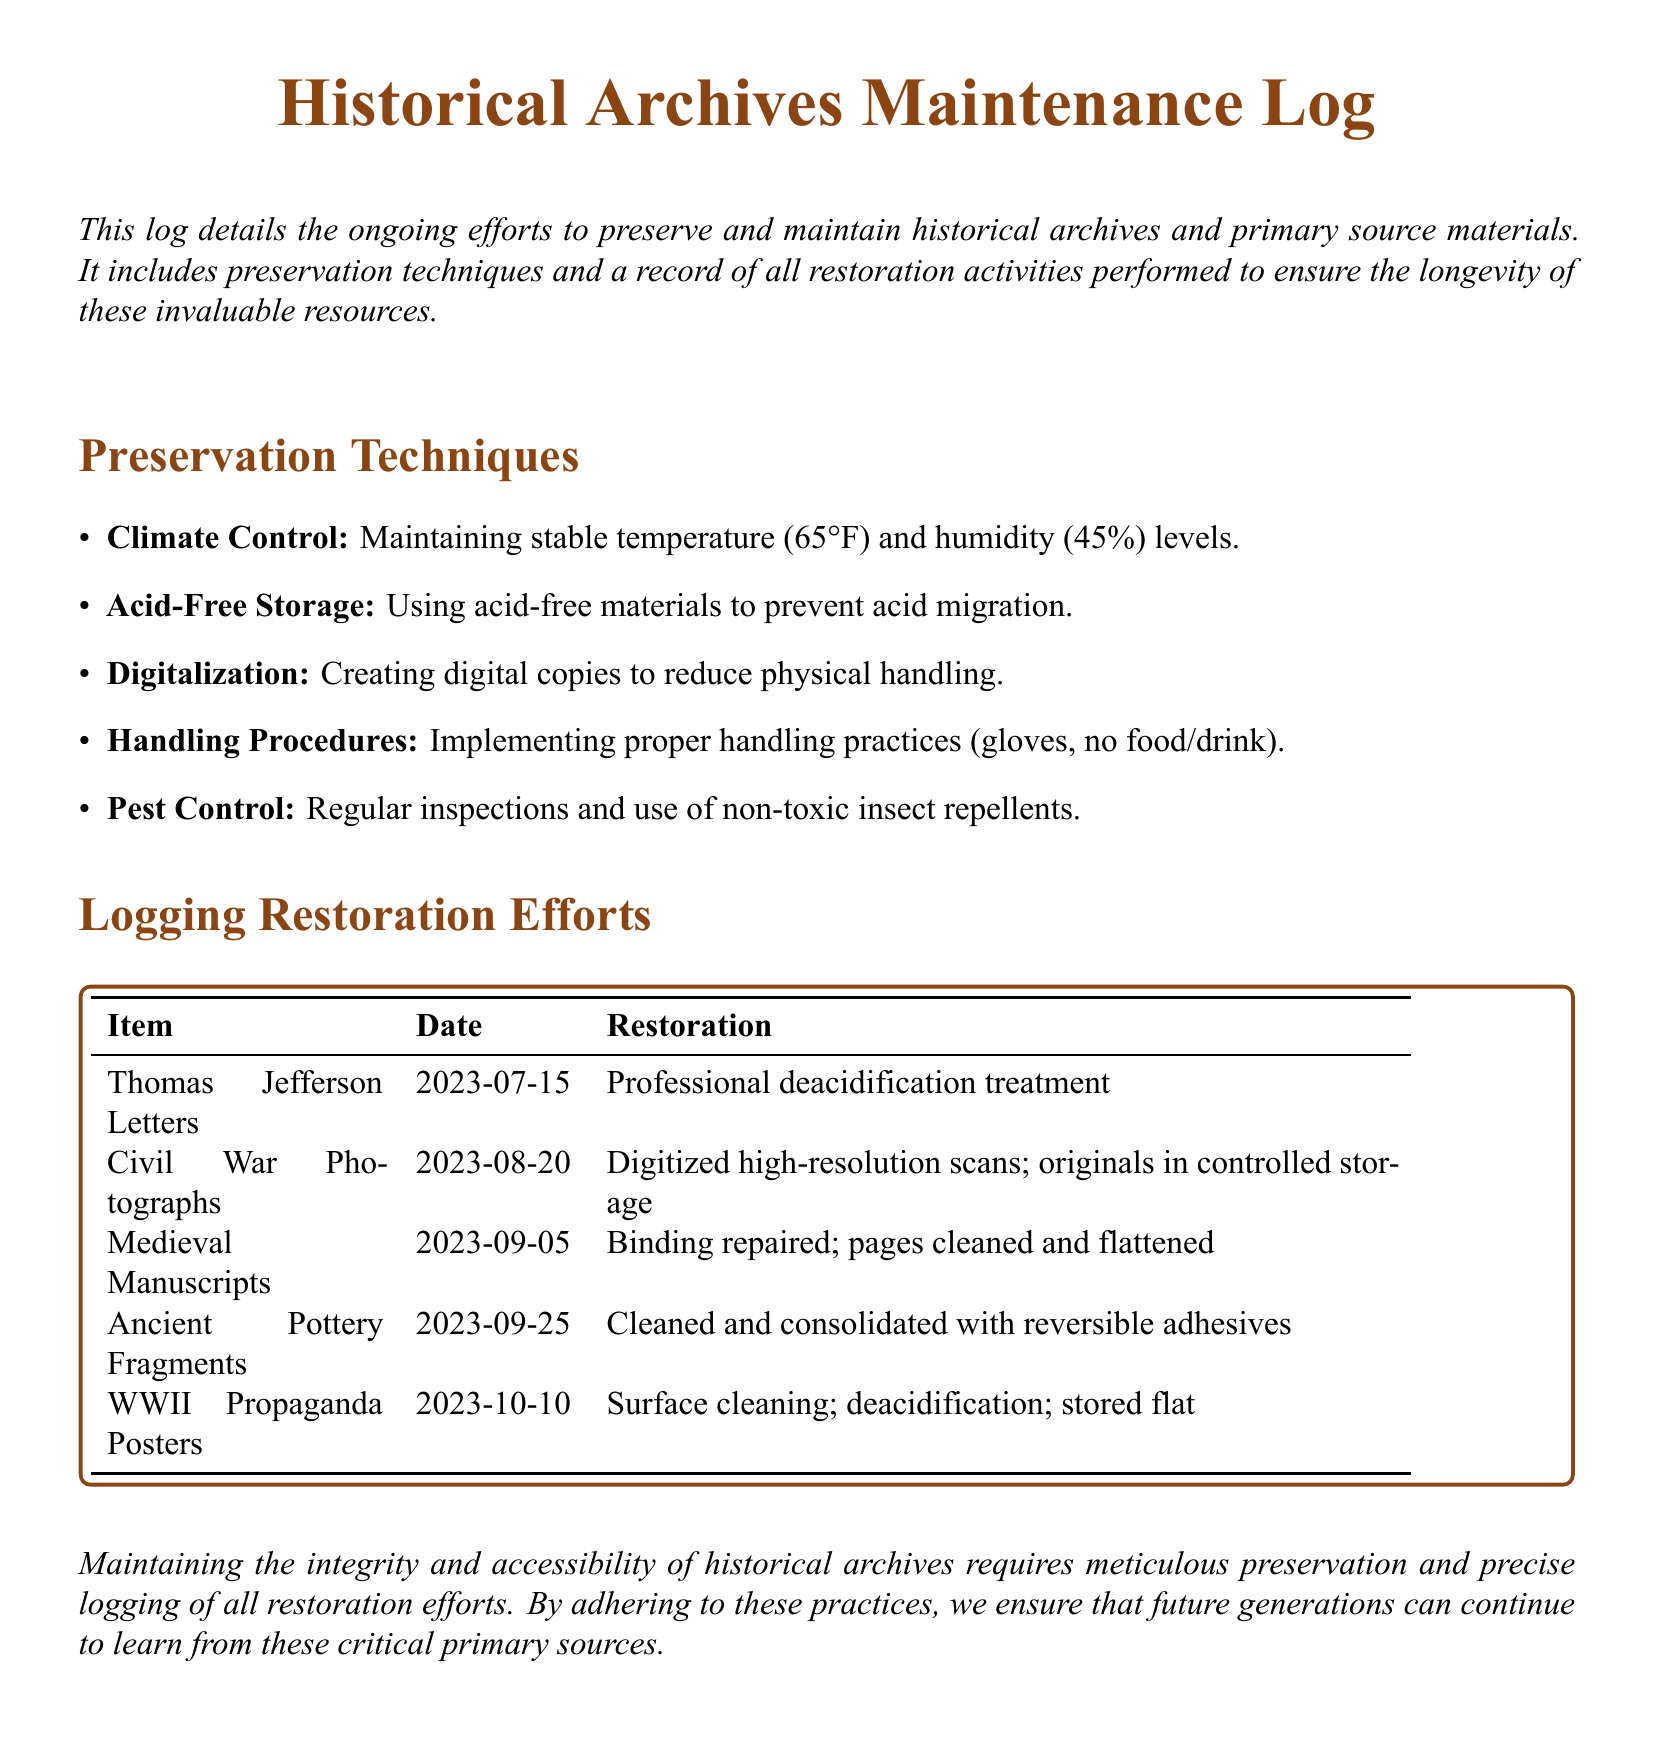What is the stable temperature maintained in archives? The document states that the stable temperature maintained is 65°F.
Answer: 65°F What is the humidity level maintained in archives? The log mentions maintaining a humidity level of 45%.
Answer: 45% What restoration was performed on the Thomas Jefferson Letters? The document specifies that a professional deacidification treatment was performed on the letters.
Answer: Professional deacidification treatment On what date were the Civil War Photographs digitized? The entry notes that the digitization of high-resolution scans occurred on August 20, 2023.
Answer: 2023-08-20 What restoration technique is applied to Medieval Manuscripts? It is indicated that the binding was repaired and pages were cleaned and flattened.
Answer: Binding repaired; pages cleaned and flattened How many preservation techniques are listed in the document? A count of the techniques reveals there are five listed preservation techniques.
Answer: Five Which item underwent surface cleaning and deacidification on October 10, 2023? The document states that the WWII Propaganda Posters underwent both surface cleaning and deacidification.
Answer: WWII Propaganda Posters What type of materials are used for acid-free storage? The log mentions using acid-free materials to prevent acid migration.
Answer: Acid-free materials What preventive measure is taken against pests? Regular inspections and use of non-toxic insect repellents are the preventive measures mentioned.
Answer: Non-toxic insect repellents 